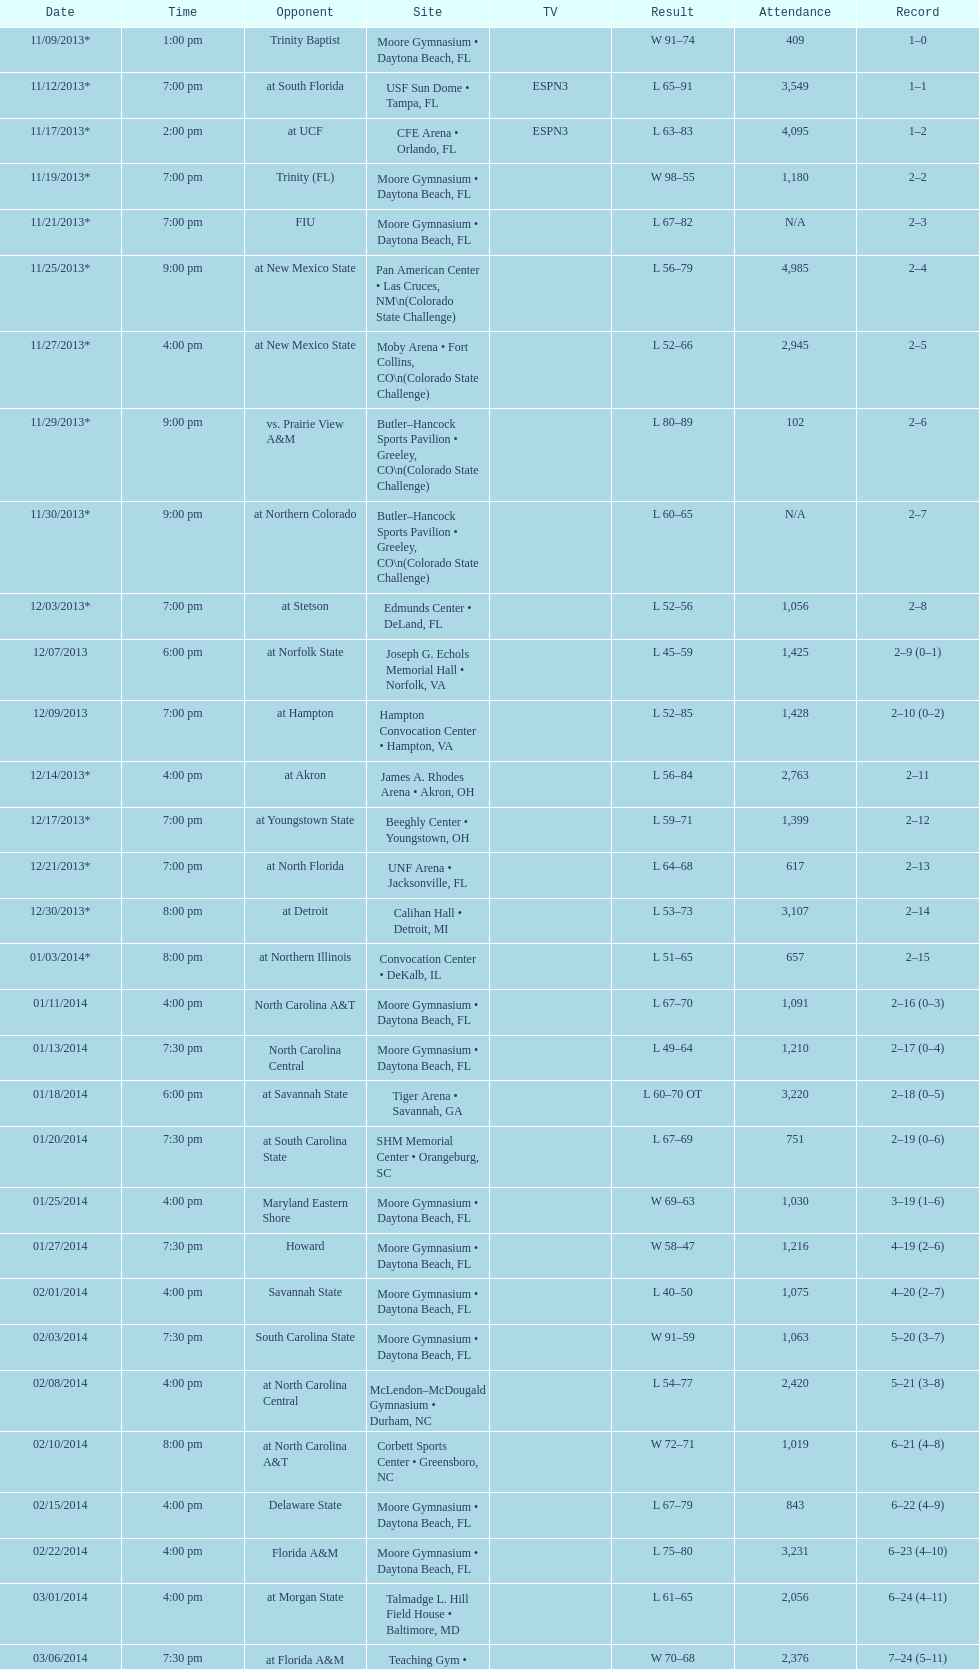What is the total attendance on 11/09/2013? 409. 